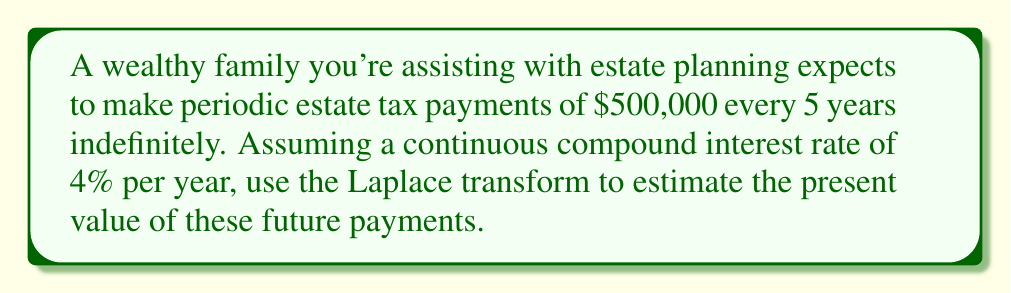Help me with this question. To solve this problem, we'll use the Laplace transform method:

1) Let's define the function $f(t)$ as a series of impulses:

   $f(t) = 500000 \sum_{n=0}^{\infty} \delta(t - 5n)$

   where $\delta(t)$ is the Dirac delta function.

2) The Laplace transform of this function is:

   $F(s) = \mathcal{L}\{f(t)\} = 500000 \sum_{n=0}^{\infty} e^{-5ns}$

3) This is a geometric series with first term $a=500000$ and ratio $r=e^{-5s}$. The sum of an infinite geometric series is given by $\frac{a}{1-r}$, so:

   $F(s) = \frac{500000}{1-e^{-5s}}$

4) To find the present value, we need to evaluate $F(s)$ at $s=0.04$ (the interest rate):

   $PV = F(0.04) = \frac{500000}{1-e^{-5(0.04)}}$

5) Calculating this:

   $PV = \frac{500000}{1-e^{-0.2}} = \frac{500000}{1-0.81873} = \frac{500000}{0.18127} \approx 2,758,867$

Therefore, the present value of these future payments is approximately $2,758,867.
Answer: $2,758,867 